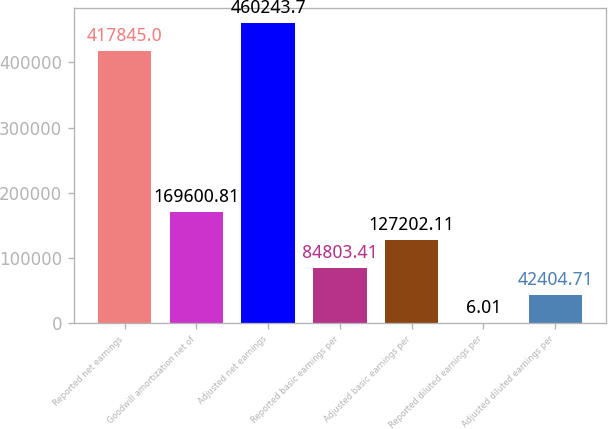<chart> <loc_0><loc_0><loc_500><loc_500><bar_chart><fcel>Reported net earnings<fcel>Goodwill amortization net of<fcel>Adjusted net earnings<fcel>Reported basic earnings per<fcel>Adjusted basic earnings per<fcel>Reported diluted earnings per<fcel>Adjusted diluted earnings per<nl><fcel>417845<fcel>169601<fcel>460244<fcel>84803.4<fcel>127202<fcel>6.01<fcel>42404.7<nl></chart> 